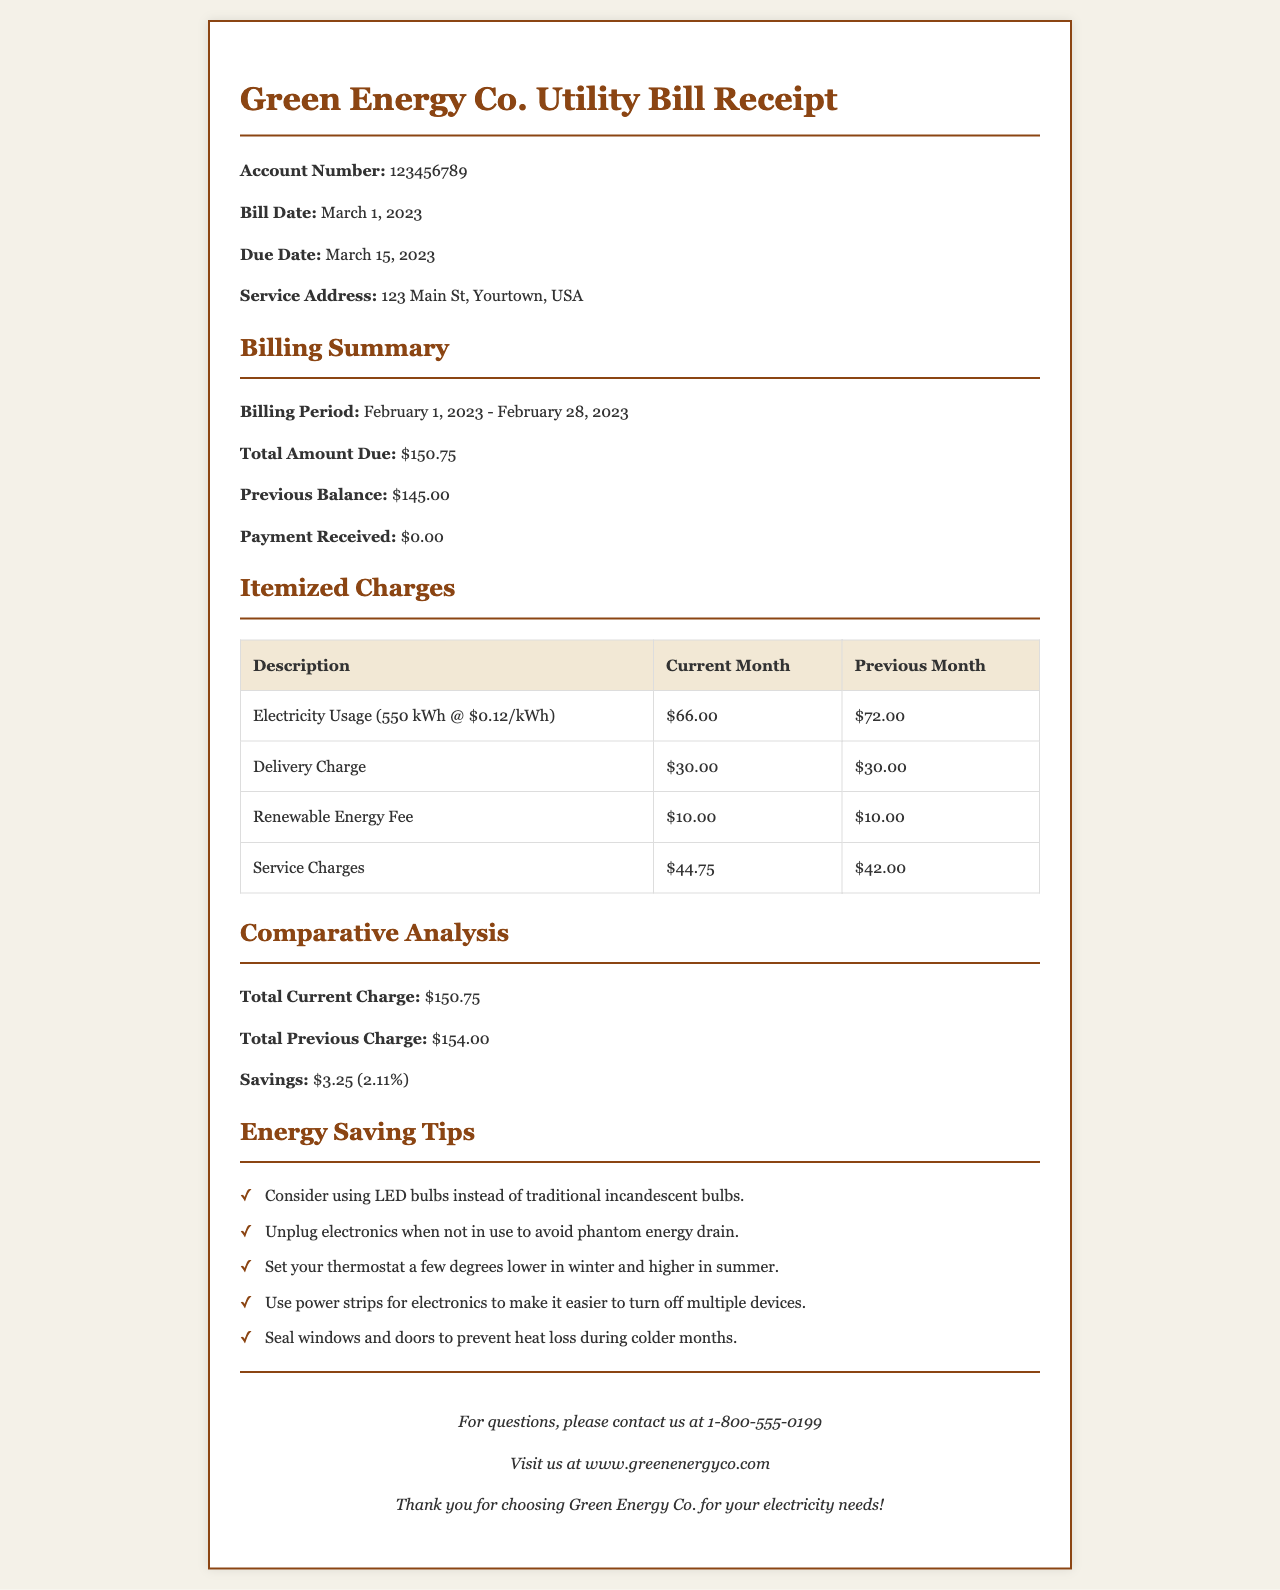what is the account number? The account number is provided in the header section of the receipt, which is 123456789.
Answer: 123456789 what is the total amount due for February 2023? The document states that the total amount due is $150.75 for the billing period of February 2023.
Answer: $150.75 how much was the electricity usage charge for the current month? The electricity usage charge for February 2023 is shown in the itemized charges as $66.00.
Answer: $66.00 what was the previous balance before this bill? The previous balance is mentioned in the summary section as $145.00.
Answer: $145.00 what savings did the customer achieve compared to the previous month? The savings from the previous month to the current month is indicated in the comparative analysis as $3.25.
Answer: $3.25 how many kilowatt-hours were used in February 2023? The electricity usage for the current month is detailed as 550 kWh in the itemized charges.
Answer: 550 kWh what is one energy-saving tip mentioned in the document? The document provides several tips; one is to "Consider using LED bulbs instead of traditional incandescent bulbs."
Answer: Consider using LED bulbs instead of traditional incandescent bulbs what is the due date for this bill? The due date is found in the header section and is specified as March 15, 2023.
Answer: March 15, 2023 how much did the service charges increase from previous month? The service charges for the current month are $44.75, and for the previous month, they were $42.00; the increase is thus $2.75.
Answer: $2.75 